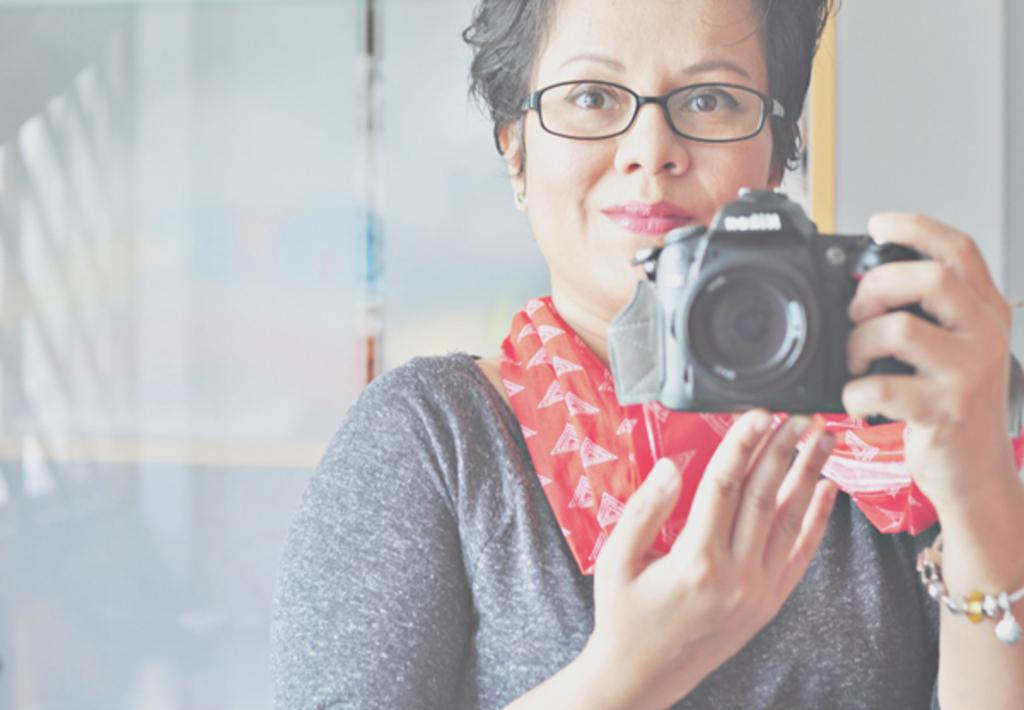Who is the main subject in the image? There is a woman in the image. What is the woman holding in her hand? The woman is carrying a camera in her hand. What type of toad can be seen sitting on the woman's shoulder in the image? There is no toad present in the image; the woman is carrying a camera in her hand. 